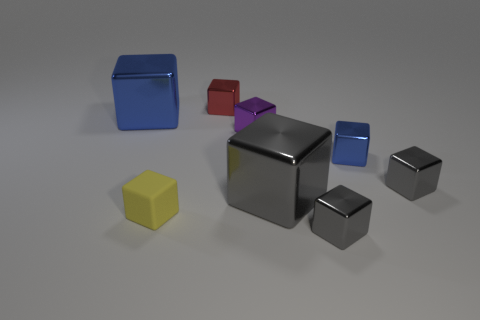Is there any other thing that has the same material as the tiny yellow object?
Offer a terse response. No. There is a red thing; what number of blue cubes are to the left of it?
Offer a very short reply. 1. What is the size of the other blue shiny object that is the same shape as the small blue metallic object?
Your answer should be compact. Large. There is a block that is to the left of the tiny red block and behind the small yellow thing; what size is it?
Make the answer very short. Large. How many yellow things are either small matte cubes or small metallic objects?
Make the answer very short. 1. What is the shape of the purple metallic thing?
Provide a short and direct response. Cube. What number of other objects are the same shape as the rubber thing?
Offer a terse response. 7. There is a shiny block that is left of the tiny matte cube; what color is it?
Provide a short and direct response. Blue. Are the yellow cube and the purple thing made of the same material?
Ensure brevity in your answer.  No. How many objects are big cyan matte cylinders or blue metallic blocks to the right of the tiny purple metal cube?
Your answer should be compact. 1. 